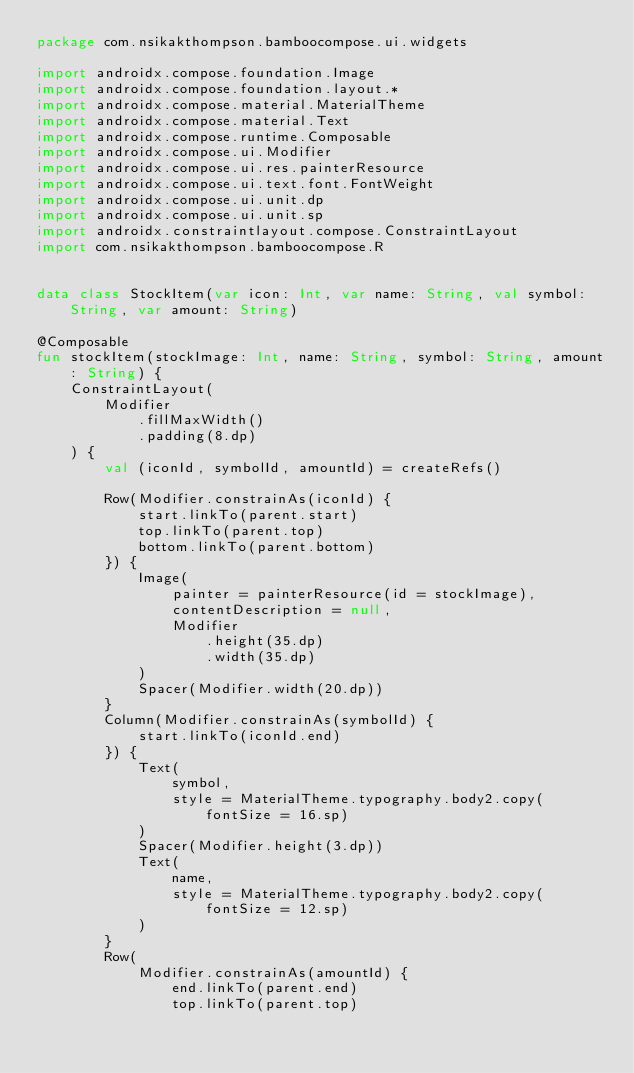Convert code to text. <code><loc_0><loc_0><loc_500><loc_500><_Kotlin_>package com.nsikakthompson.bamboocompose.ui.widgets

import androidx.compose.foundation.Image
import androidx.compose.foundation.layout.*
import androidx.compose.material.MaterialTheme
import androidx.compose.material.Text
import androidx.compose.runtime.Composable
import androidx.compose.ui.Modifier
import androidx.compose.ui.res.painterResource
import androidx.compose.ui.text.font.FontWeight
import androidx.compose.ui.unit.dp
import androidx.compose.ui.unit.sp
import androidx.constraintlayout.compose.ConstraintLayout
import com.nsikakthompson.bamboocompose.R


data class StockItem(var icon: Int, var name: String, val symbol: String, var amount: String)

@Composable
fun stockItem(stockImage: Int, name: String, symbol: String, amount: String) {
    ConstraintLayout(
        Modifier
            .fillMaxWidth()
            .padding(8.dp)
    ) {
        val (iconId, symbolId, amountId) = createRefs()

        Row(Modifier.constrainAs(iconId) {
            start.linkTo(parent.start)
            top.linkTo(parent.top)
            bottom.linkTo(parent.bottom)
        }) {
            Image(
                painter = painterResource(id = stockImage),
                contentDescription = null,
                Modifier
                    .height(35.dp)
                    .width(35.dp)
            )
            Spacer(Modifier.width(20.dp))
        }
        Column(Modifier.constrainAs(symbolId) {
            start.linkTo(iconId.end)
        }) {
            Text(
                symbol,
                style = MaterialTheme.typography.body2.copy(fontSize = 16.sp)
            )
            Spacer(Modifier.height(3.dp))
            Text(
                name,
                style = MaterialTheme.typography.body2.copy(fontSize = 12.sp)
            )
        }
        Row(
            Modifier.constrainAs(amountId) {
                end.linkTo(parent.end)
                top.linkTo(parent.top)</code> 